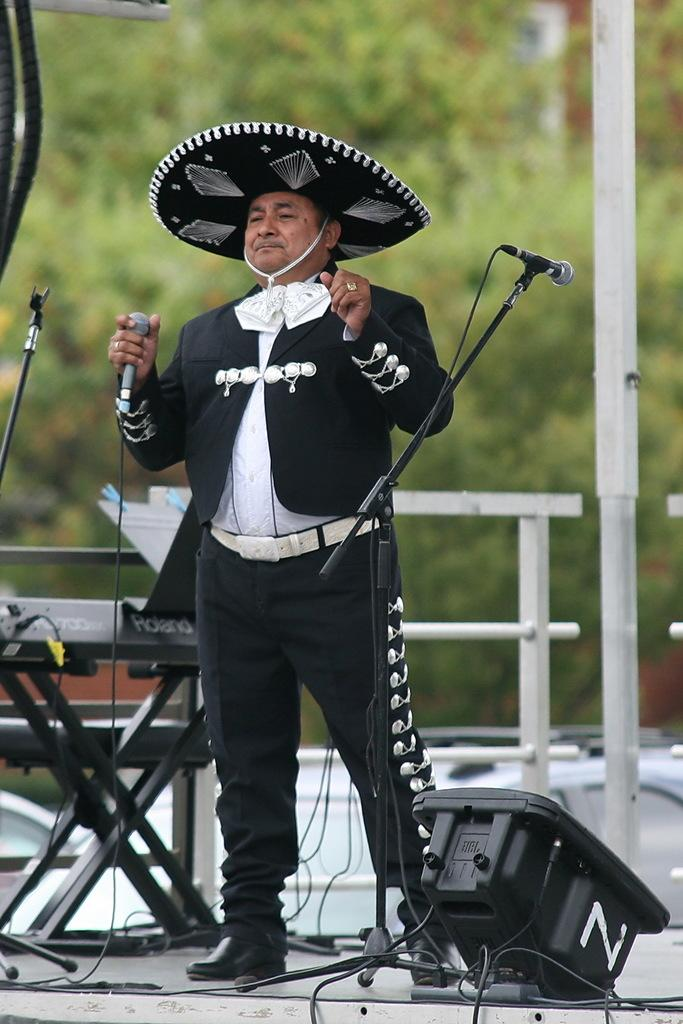What is the person in the image doing? The person is standing in the image and holding a mic. How many mics can be seen in the image? There are additional mics in the image, along with the one the person is holding. What are the stands in the image used for? The stands in the image are likely used to hold the mics. What is the pole in the image used for? The purpose of the pole in the image is not clear from the provided facts. Can you describe any other objects in the image? There are other objects in the image, but their specific details are not mentioned in the facts. What can be seen in the background of the image? There is a vehicle and trees visible in the background. Where is the hydrant located in the image? There is no hydrant present in the image. What type of camera is being used by the person in the image? There is no camera visible in the image; the person is holding a mic. 